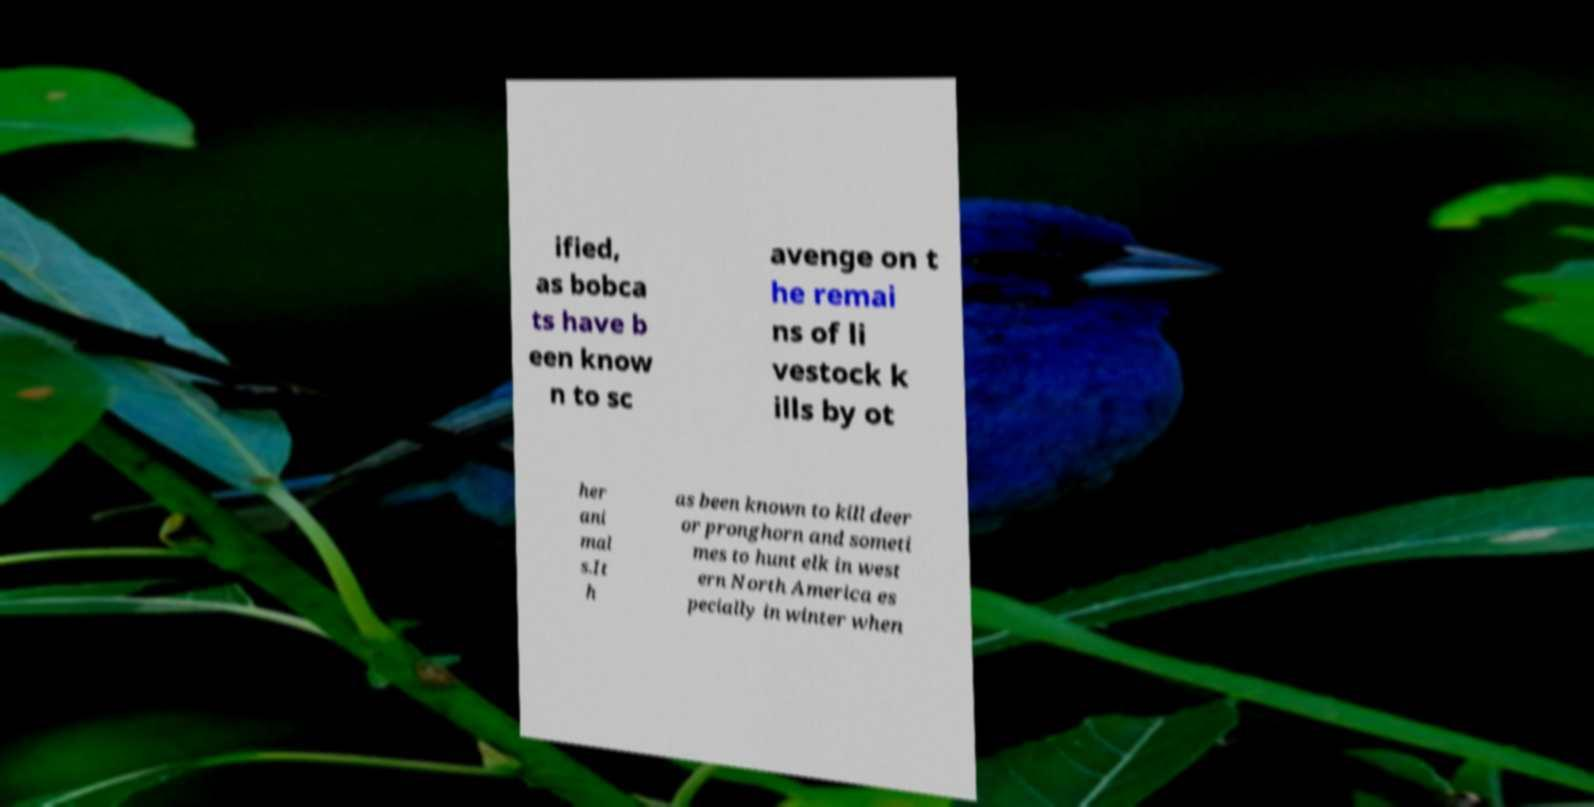Please read and relay the text visible in this image. What does it say? ified, as bobca ts have b een know n to sc avenge on t he remai ns of li vestock k ills by ot her ani mal s.It h as been known to kill deer or pronghorn and someti mes to hunt elk in west ern North America es pecially in winter when 